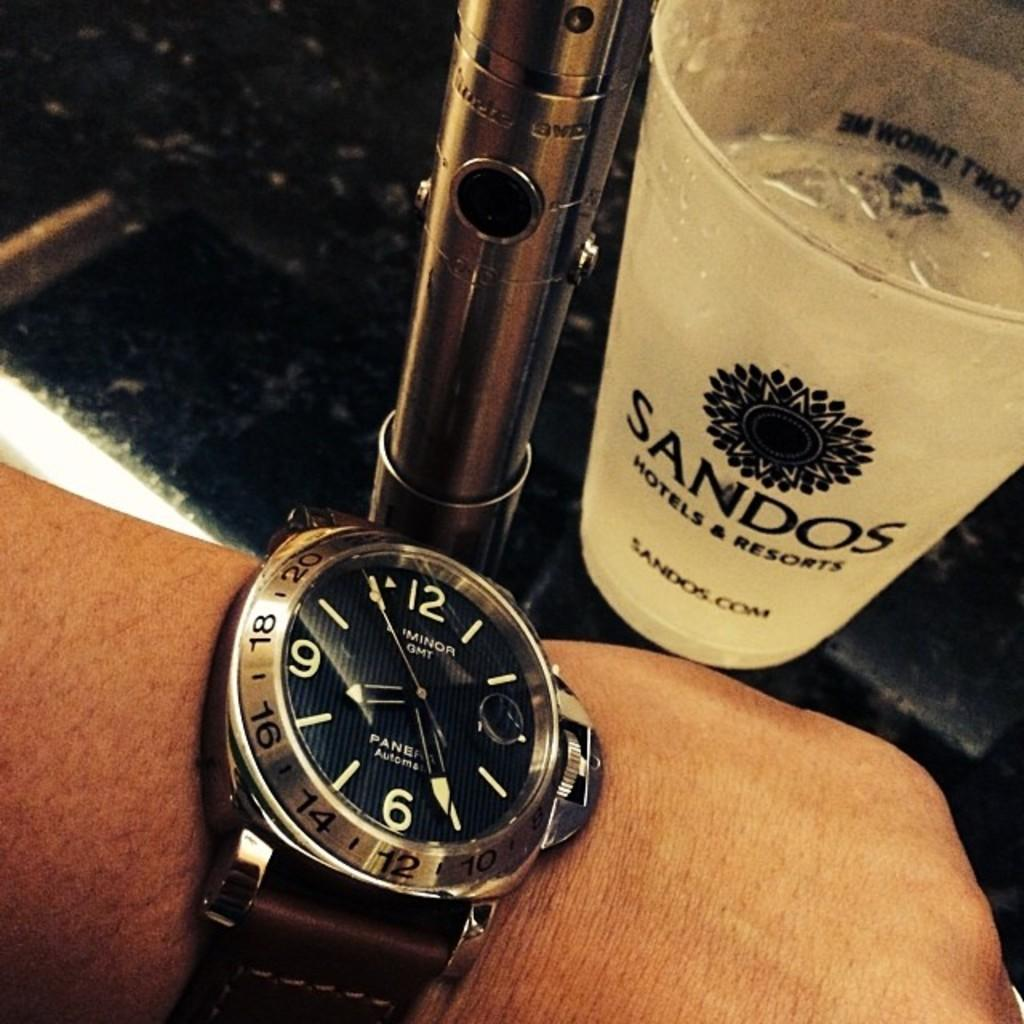<image>
Relay a brief, clear account of the picture shown. a hand and watch in front of a Sandos Hotels & Resorts cup 